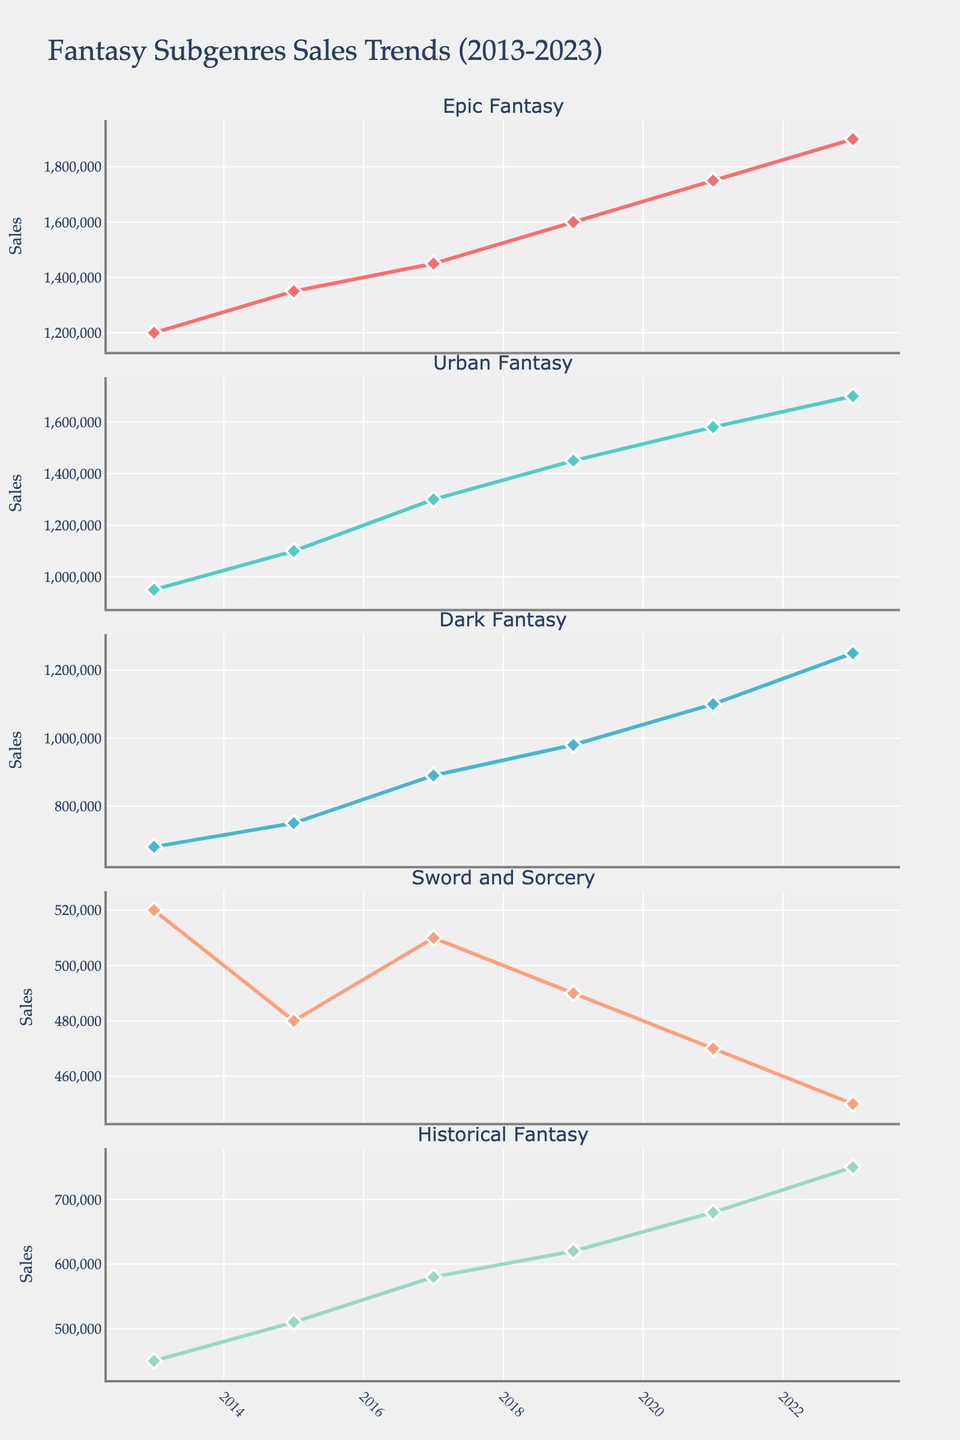What's the title of the figure? The title is located at the top of the figure.
Answer: Career Goals of Top 5 Football Players (2013-2023) Which player scored the most goals in a single season, and in which season was it? Robert Lewandowski scored 55 goals in the 2019/20 season. This information is visible in the subplot corresponding to Robert Lewandowski, and his highest data point is 55 in the 2019/20 season.
Answer: Robert Lewandowski in 2019/20 Compare Lionel Messi and Cristiano Ronaldo's goals in the 2014/15 season. Who scored more and by how many goals? Lionel Messi scored 58 goals, and Cristiano Ronaldo scored 61 goals in the 2014/15 season. The difference between their goals is 61 - 58 = 3.
Answer: Cristiano Ronaldo by 3 goals How many goals did Neymar score in total during the seasons from 2013/14 to 2017/18? Neymar's goals for each season from 2013/14 to 2017/18 are 15, 39, 31, 20, and 28. Summing them up: 15 + 39 + 31 + 20 + 28 = 133.
Answer: 133 What is the trend of Harry Kane's goals over the ten seasons? Observing Harry Kane's subplot, there is an increasing trend from 2013/14 to 2017/18 from 4 to 41 goals. A slight drop and fluctuations follow until 2022/23 where he scored 32 goals.
Answer: Increasing then fluctuating In which season did Lionel Messi experience the most significant drop in goals compared to the previous season? Comparing Lionel Messi's goals each season, the most significant drop is between 2020/21 and 2021/22 where his goals decreased from 38 to 11. The difference is 38 - 11 = 27.
Answer: 2021/22 Between whom is the closest goal count observed in the 2022/23 season? In the 2022/23 season, Robert Lewandowski scored 33 goals, and Harry Kane scored 32 goals. The closest goal count difference is 33 - 32 = 1.
Answer: Robert Lewandowski and Harry Kane What is the average number of goals per season for Cristiano Ronaldo over the decade? The total goals over the ten seasons for Cristiano Ronaldo are summed: 51, 61, 51, 42, 44, 28, 37, 36, 24, 14, which sums to 388. Dividing by 10 gives the average, 388 / 10 = 38.8.
Answer: 38.8 Identify the season where Neymar scored the least number of goals and specify the number. Observing Neymar's subplot, the season with the least goals is 2021/22 where he scored 13 goals.
Answer: 2021/22, 13 goals 